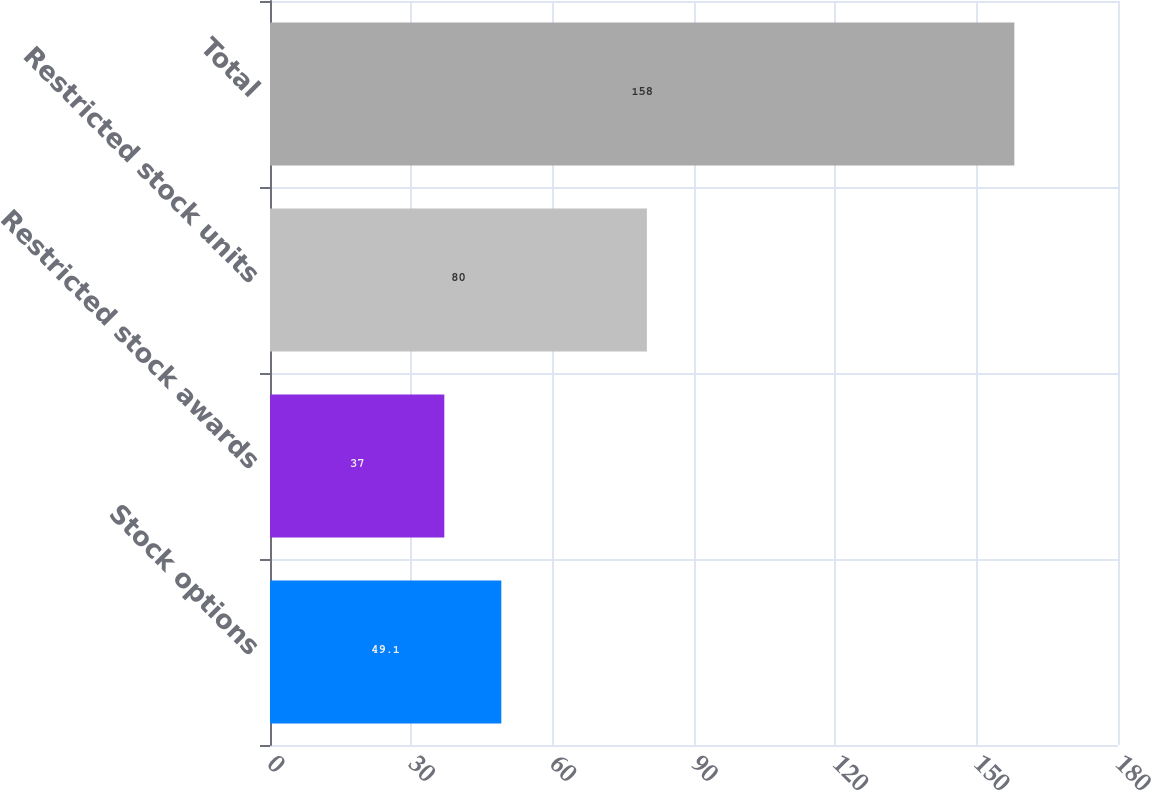<chart> <loc_0><loc_0><loc_500><loc_500><bar_chart><fcel>Stock options<fcel>Restricted stock awards<fcel>Restricted stock units<fcel>Total<nl><fcel>49.1<fcel>37<fcel>80<fcel>158<nl></chart> 